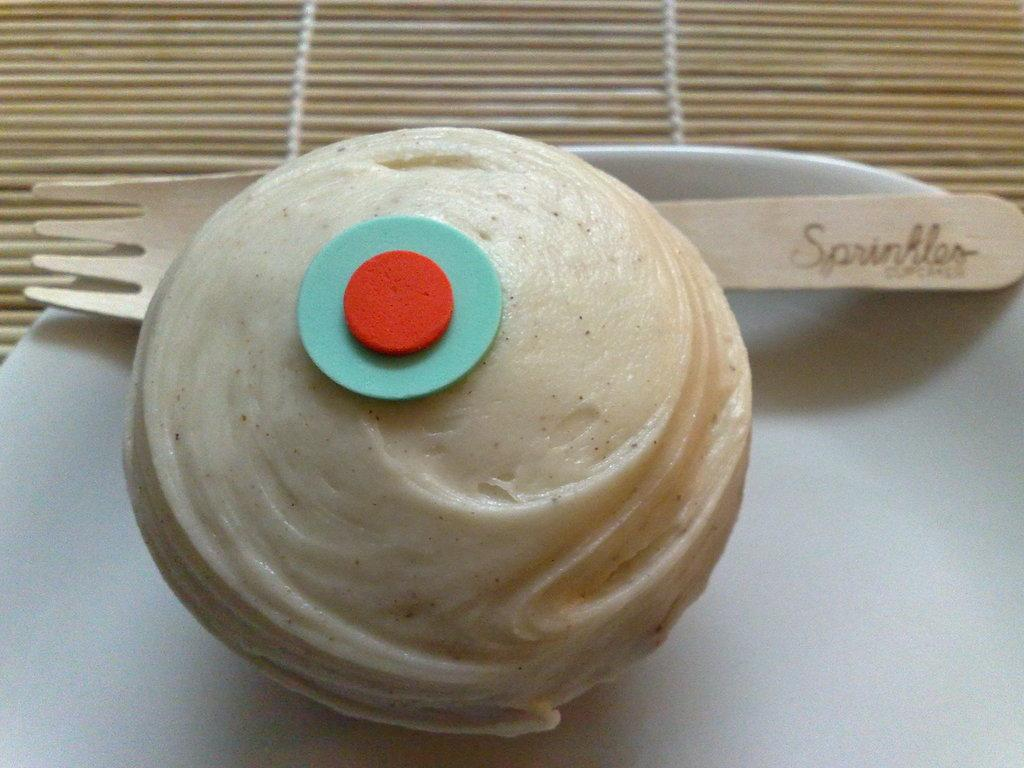What type of food can be seen in the image? There is food in the image, but the specific type cannot be determined from the provided facts. What utensil is present in the image? There is a spoon in the image. What is the food placed on in the image? There is a plate on a surface in the image. What type of spade is being used to serve the food in the image? There is no spade present in the image; only a spoon and a plate are visible. Can you see a cat eating the food in the image? There is no cat present in the image; the focus is on the food, spoon, and plate. 